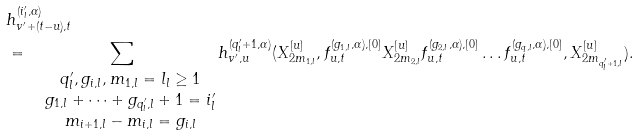<formula> <loc_0><loc_0><loc_500><loc_500>& h _ { v ^ { \prime } + ( t - u ) , t } ^ { ( i _ { l } ^ { \prime } , \alpha ) } \\ & = \sum _ { \begin{matrix} & q ^ { \prime } _ { l } , g _ { i , l } , m _ { 1 , l } = l _ { l } \geq 1 \\ & g _ { 1 , l } + \dots + g _ { q ^ { \prime } _ { l } , l } + 1 = i _ { l } ^ { \prime } \\ & m _ { i + 1 , l } - m _ { i , l } = g _ { i , l } \end{matrix} } h _ { v ^ { \prime } , u } ^ { ( q ^ { \prime } _ { l } + 1 , \alpha ) } ( X _ { 2 m _ { 1 , l } } ^ { [ u ] } , f _ { u , t } ^ { ( g _ { 1 , l } , \alpha ) , [ 0 ] } X _ { 2 m _ { 2 , l } } ^ { [ u ] } f _ { u , t } ^ { ( g _ { 2 , l } , \alpha ) , [ 0 ] } \dots f _ { u , t } ^ { ( g _ { q , l } , \alpha ) , [ 0 ] } , X _ { 2 m _ { q ^ { \prime } _ { l } + 1 , l } } ^ { [ u ] } ) .</formula> 